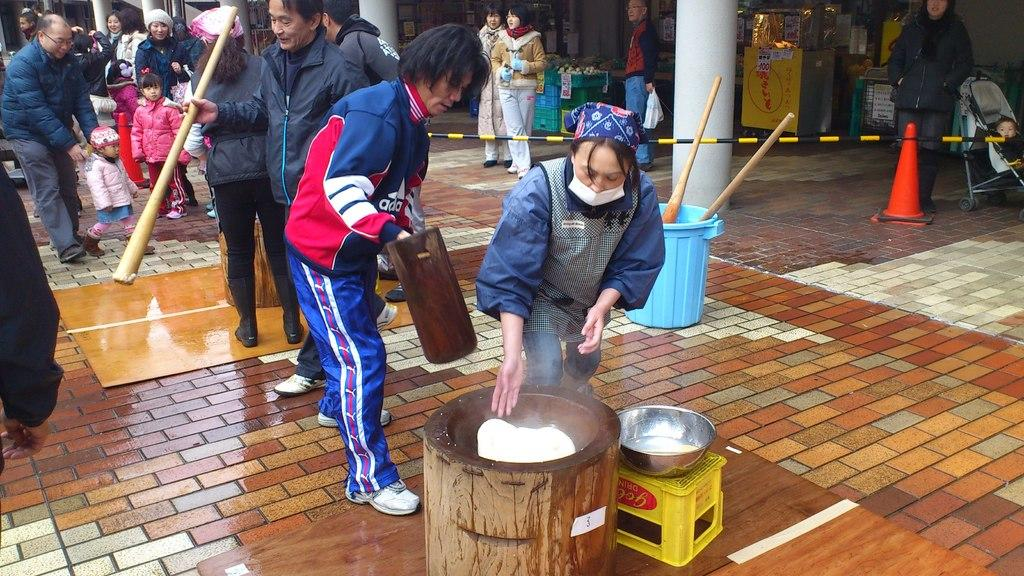Who or what can be seen in the image? There are people in the image. What type of structures are visible in the image? There are buildings in the image. What object is used for traffic control in the image? A traffic cone is present in the image. What container is visible in the image? There is a bowl in the image. What piece of furniture is visible in the image? A stool is visible in the image. What musical instrument is present in the image? There is a drum in the image. How does the fan amuse the people in the image? There is no fan present in the image, so it cannot amuse the people. What type of wind can be seen blowing the objects in the image? There is no wind blowing objects in the image; it is a still image. 